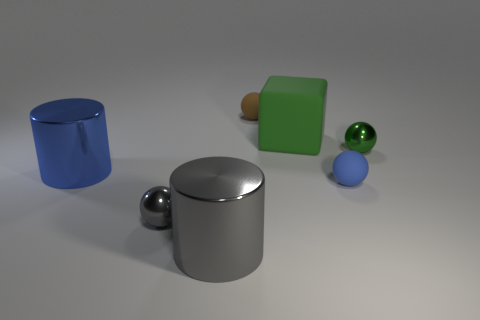There is a small object that is both on the left side of the large green matte object and in front of the brown thing; what is its shape?
Your response must be concise. Sphere. What number of small things are rubber things or objects?
Provide a succinct answer. 4. What is the block made of?
Your answer should be very brief. Rubber. What number of other things are the same shape as the blue metallic thing?
Your answer should be very brief. 1. How big is the green metal thing?
Keep it short and to the point. Small. There is a metal object that is both behind the gray shiny ball and left of the gray shiny cylinder; how big is it?
Make the answer very short. Large. What is the shape of the blue object in front of the blue cylinder?
Your answer should be compact. Sphere. Is the material of the big blue object the same as the blue object that is on the right side of the big block?
Ensure brevity in your answer.  No. Does the blue metal thing have the same shape as the green rubber object?
Offer a terse response. No. There is a blue thing that is the same shape as the tiny gray shiny object; what is its material?
Ensure brevity in your answer.  Rubber. 